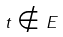<formula> <loc_0><loc_0><loc_500><loc_500>t \notin E</formula> 